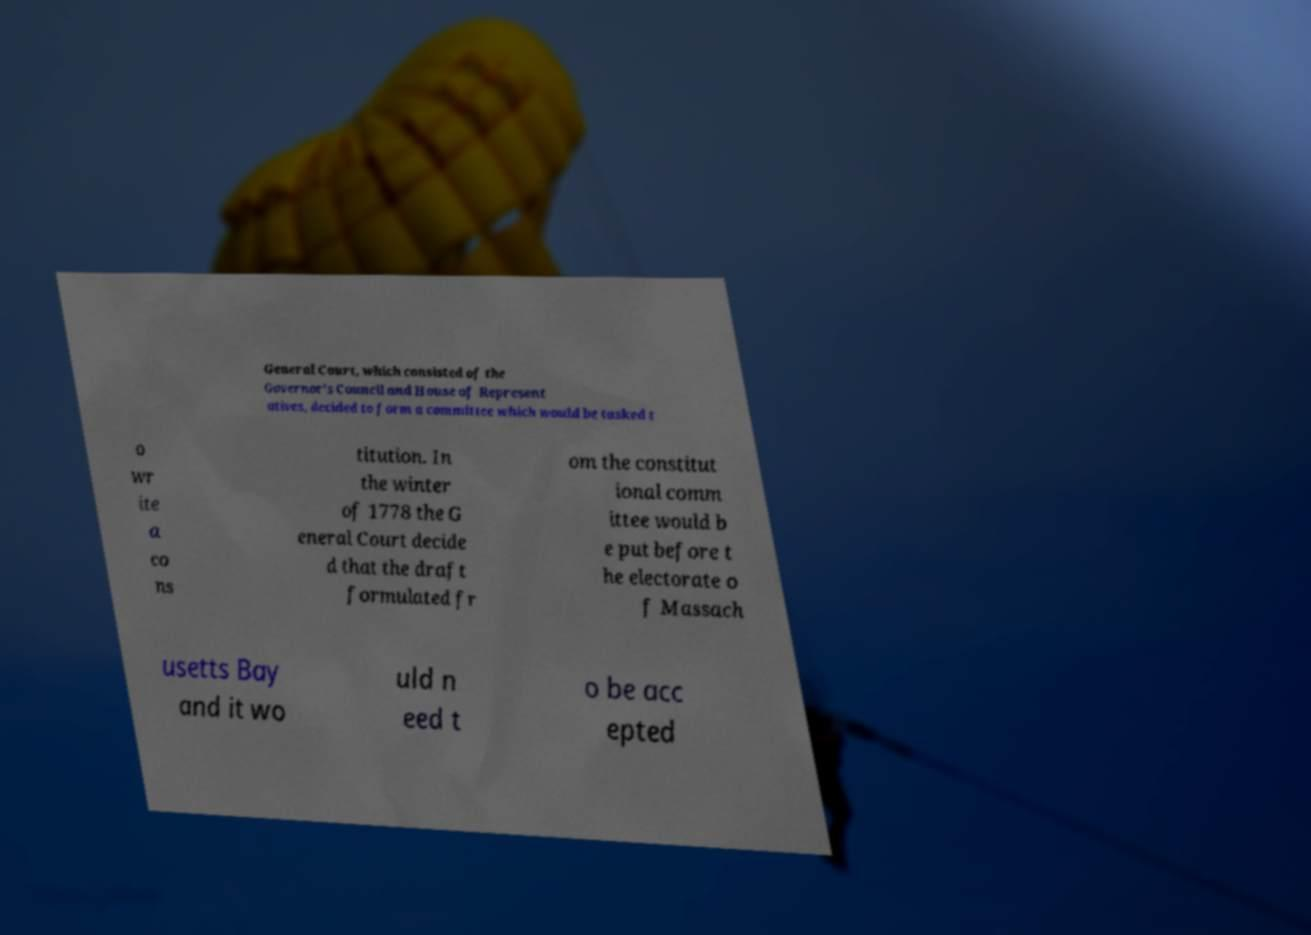Could you extract and type out the text from this image? General Court, which consisted of the Governor's Council and House of Represent atives, decided to form a committee which would be tasked t o wr ite a co ns titution. In the winter of 1778 the G eneral Court decide d that the draft formulated fr om the constitut ional comm ittee would b e put before t he electorate o f Massach usetts Bay and it wo uld n eed t o be acc epted 